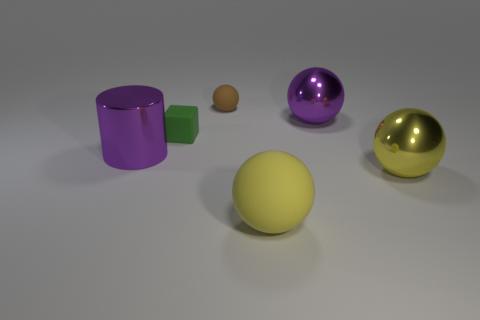Are there any other purple shiny balls of the same size as the purple sphere?
Offer a terse response. No. There is another sphere that is made of the same material as the purple ball; what color is it?
Your answer should be compact. Yellow. What material is the big purple ball?
Offer a terse response. Metal. What is the shape of the small green rubber thing?
Offer a very short reply. Cube. What number of tiny matte balls have the same color as the metallic cylinder?
Give a very brief answer. 0. What is the material of the purple object on the right side of the matte ball that is in front of the purple object that is on the left side of the big matte ball?
Offer a very short reply. Metal. What number of purple objects are blocks or big shiny balls?
Your answer should be very brief. 1. There is a metallic object that is on the left side of the metal object that is behind the purple cylinder that is in front of the big purple shiny sphere; how big is it?
Ensure brevity in your answer.  Large. There is another metal object that is the same shape as the yellow metal thing; what size is it?
Provide a short and direct response. Large. What number of small objects are matte blocks or matte things?
Offer a very short reply. 2. 